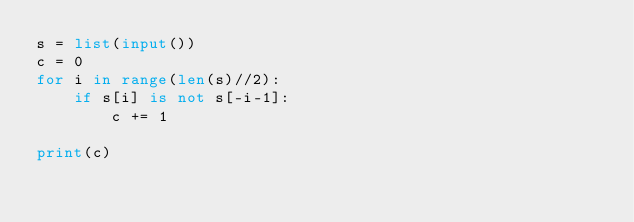<code> <loc_0><loc_0><loc_500><loc_500><_Python_>s = list(input())
c = 0
for i in range(len(s)//2):
    if s[i] is not s[-i-1]:
        c += 1

print(c)</code> 